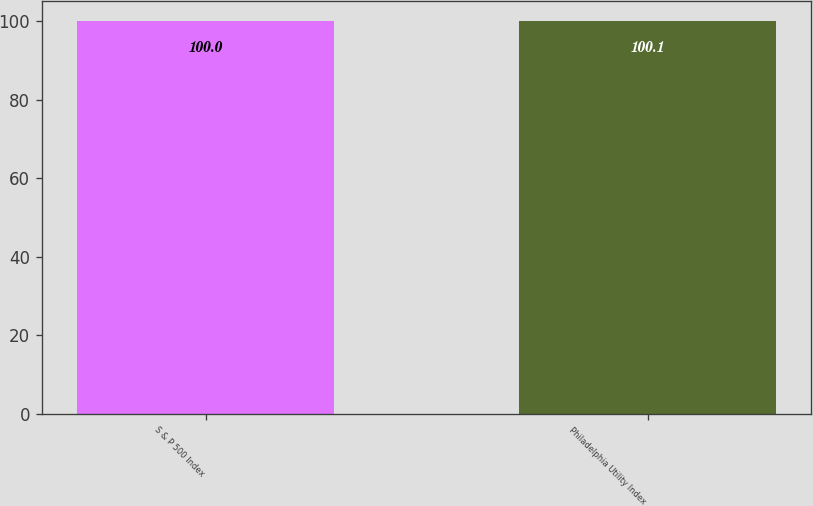Convert chart to OTSL. <chart><loc_0><loc_0><loc_500><loc_500><bar_chart><fcel>S & P 500 Index<fcel>Philadelphia Utility Index<nl><fcel>100<fcel>100.1<nl></chart> 